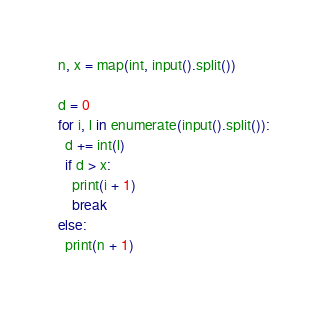<code> <loc_0><loc_0><loc_500><loc_500><_Python_>n, x = map(int, input().split())

d = 0
for i, l in enumerate(input().split()):
  d += int(l)
  if d > x:
    print(i + 1)
    break
else:
  print(n + 1)</code> 